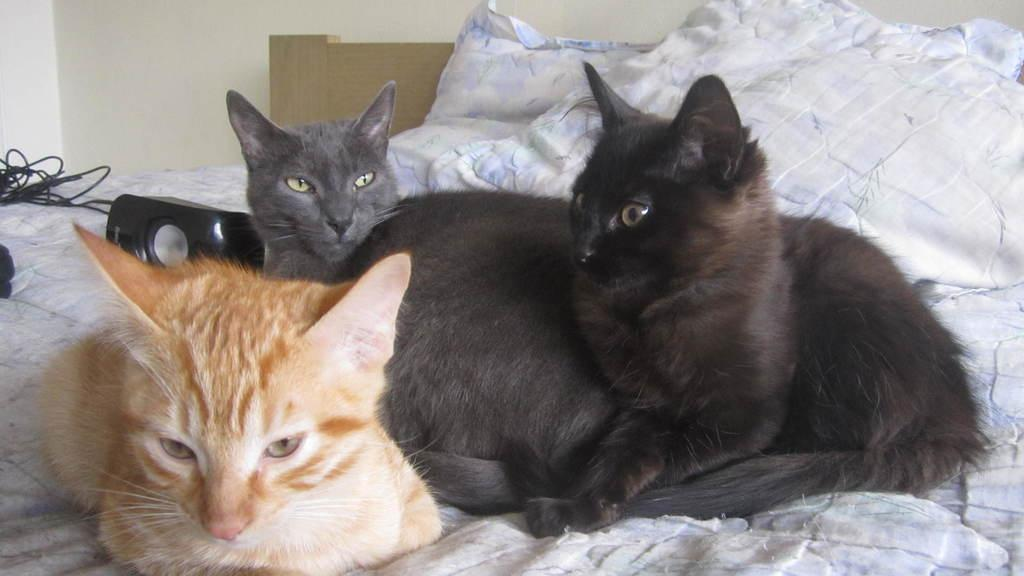How many cats are in the image? There are three cats in the image. What are the cats doing in the image? The cats are sitting on a bed. Can you describe the colors of the cats? One cat is black, another is grey, and the third is brown. What color is the bed-sheet in the image? The bed-sheet is white. What color is the wall in the image? The wall is white. Are there any goldfish swimming in the quicksand in the image? There are no goldfish or quicksand present in the image; it features three cats sitting on a bed with a white bed-sheet and a white wall. 